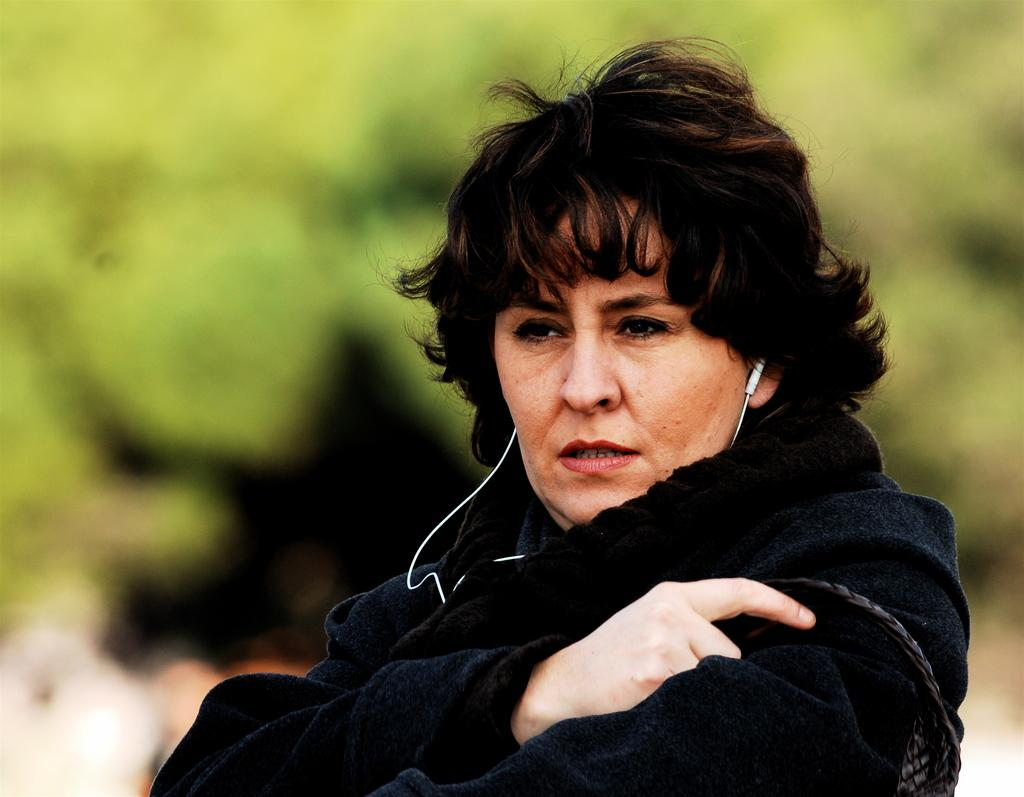Who is the main subject in the image? There is a woman in the image. What is the woman wearing? The woman is wearing a white jacket. What is the woman using in the image? The woman is using earphones. Can you describe the background of the image? The background of the image is blurred and has a green color. What type of waste can be seen in the image? There is no waste present in the image. What kind of test is the woman taking in the image? There is no test visible in the image; the woman is simply wearing earphones. 